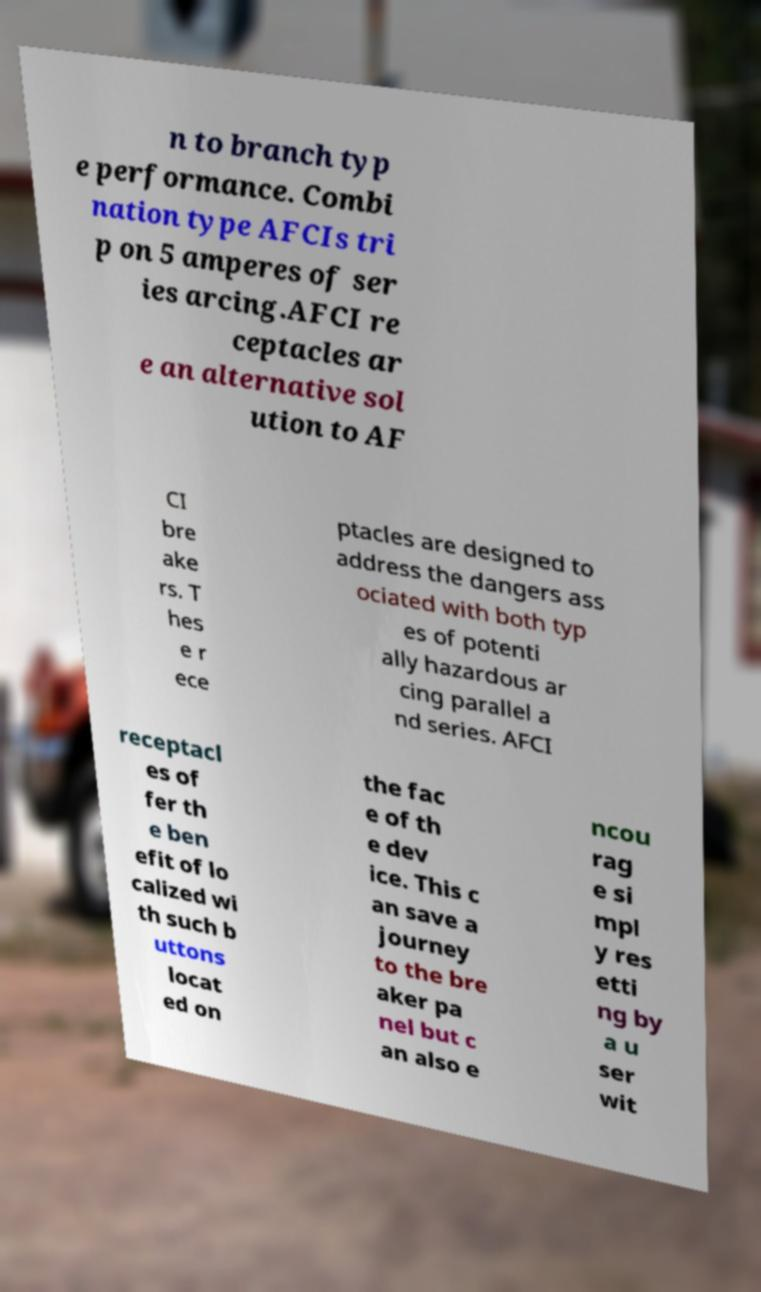Please identify and transcribe the text found in this image. n to branch typ e performance. Combi nation type AFCIs tri p on 5 amperes of ser ies arcing.AFCI re ceptacles ar e an alternative sol ution to AF CI bre ake rs. T hes e r ece ptacles are designed to address the dangers ass ociated with both typ es of potenti ally hazardous ar cing parallel a nd series. AFCI receptacl es of fer th e ben efit of lo calized wi th such b uttons locat ed on the fac e of th e dev ice. This c an save a journey to the bre aker pa nel but c an also e ncou rag e si mpl y res etti ng by a u ser wit 